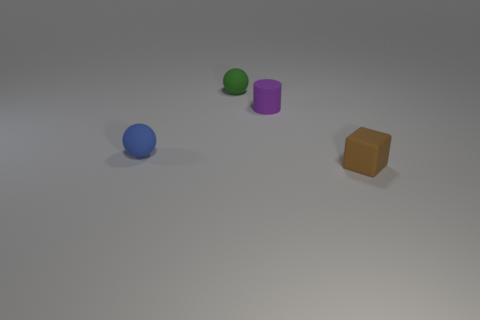Add 1 small cylinders. How many objects exist? 5 Subtract all cylinders. How many objects are left? 3 Add 1 purple rubber objects. How many purple rubber objects are left? 2 Add 3 tiny red cylinders. How many tiny red cylinders exist? 3 Subtract 0 cyan blocks. How many objects are left? 4 Subtract all purple objects. Subtract all small green things. How many objects are left? 2 